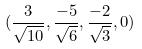<formula> <loc_0><loc_0><loc_500><loc_500>( \frac { 3 } { \sqrt { 1 0 } } , \frac { - 5 } { \sqrt { 6 } } , \frac { - 2 } { \sqrt { 3 } } , 0 )</formula> 